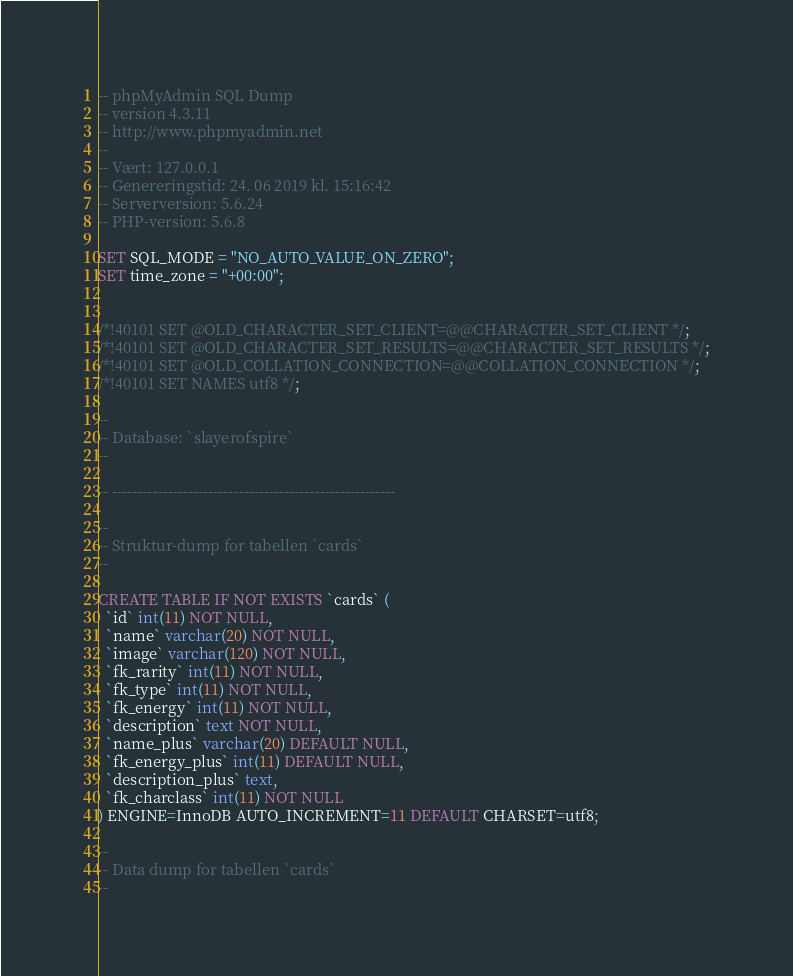Convert code to text. <code><loc_0><loc_0><loc_500><loc_500><_SQL_>-- phpMyAdmin SQL Dump
-- version 4.3.11
-- http://www.phpmyadmin.net
--
-- Vært: 127.0.0.1
-- Genereringstid: 24. 06 2019 kl. 15:16:42
-- Serverversion: 5.6.24
-- PHP-version: 5.6.8

SET SQL_MODE = "NO_AUTO_VALUE_ON_ZERO";
SET time_zone = "+00:00";


/*!40101 SET @OLD_CHARACTER_SET_CLIENT=@@CHARACTER_SET_CLIENT */;
/*!40101 SET @OLD_CHARACTER_SET_RESULTS=@@CHARACTER_SET_RESULTS */;
/*!40101 SET @OLD_COLLATION_CONNECTION=@@COLLATION_CONNECTION */;
/*!40101 SET NAMES utf8 */;

--
-- Database: `slayerofspire`
--

-- --------------------------------------------------------

--
-- Struktur-dump for tabellen `cards`
--

CREATE TABLE IF NOT EXISTS `cards` (
  `id` int(11) NOT NULL,
  `name` varchar(20) NOT NULL,
  `image` varchar(120) NOT NULL,
  `fk_rarity` int(11) NOT NULL,
  `fk_type` int(11) NOT NULL,
  `fk_energy` int(11) NOT NULL,
  `description` text NOT NULL,
  `name_plus` varchar(20) DEFAULT NULL,
  `fk_energy_plus` int(11) DEFAULT NULL,
  `description_plus` text,
  `fk_charclass` int(11) NOT NULL
) ENGINE=InnoDB AUTO_INCREMENT=11 DEFAULT CHARSET=utf8;

--
-- Data dump for tabellen `cards`
--
</code> 